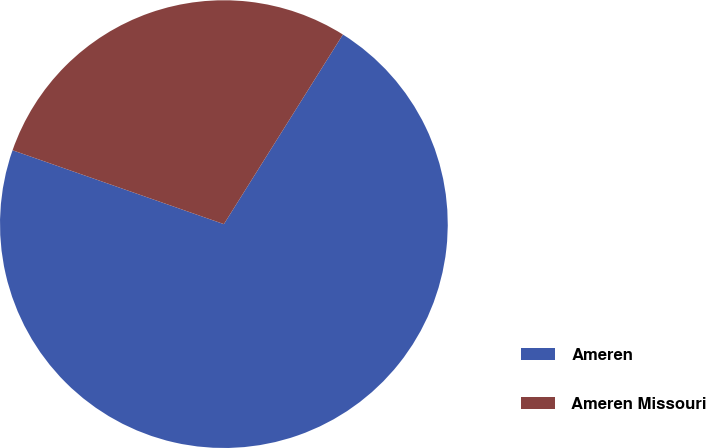Convert chart to OTSL. <chart><loc_0><loc_0><loc_500><loc_500><pie_chart><fcel>Ameren<fcel>Ameren Missouri<nl><fcel>71.43%<fcel>28.57%<nl></chart> 